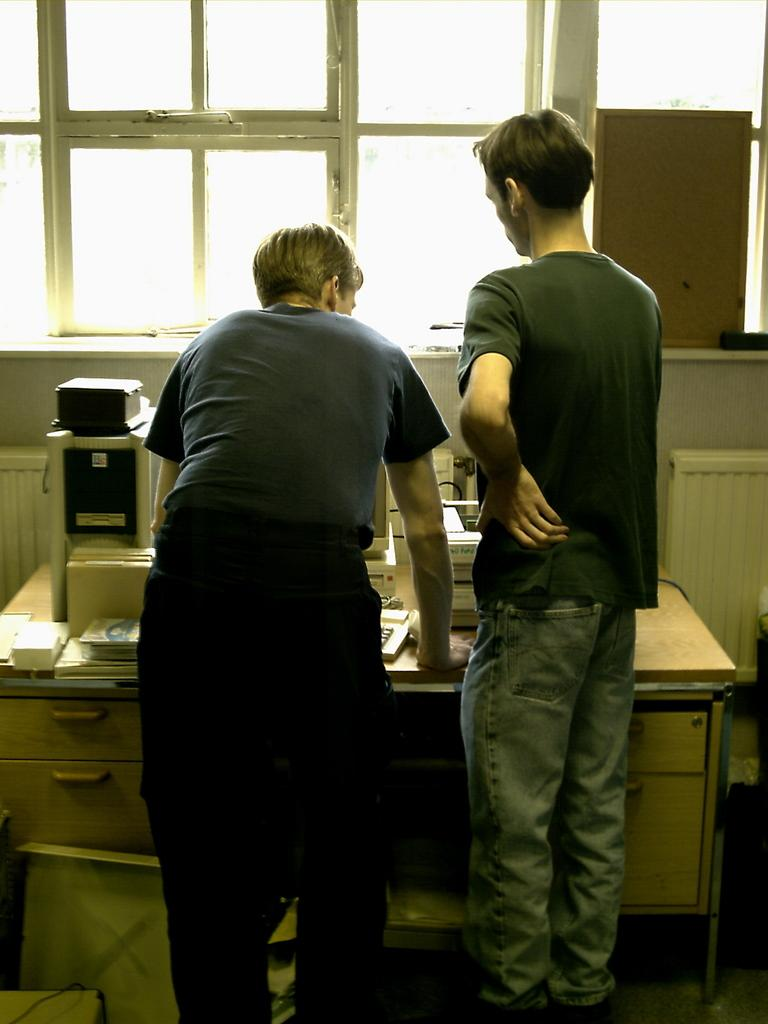How many people are in the image? There are two persons in the image. What are the persons doing in the image? The persons are standing in front of a table. What can be seen on the table in the image? There is equipment placed on the table. What is visible in the background of the image? There are windows visible in the background of the image. What type of structure can be seen in the background of the image? There is no specific structure visible in the background of the image; only windows are present. Can you describe the rail system in the image? There is no rail system present in the image. 